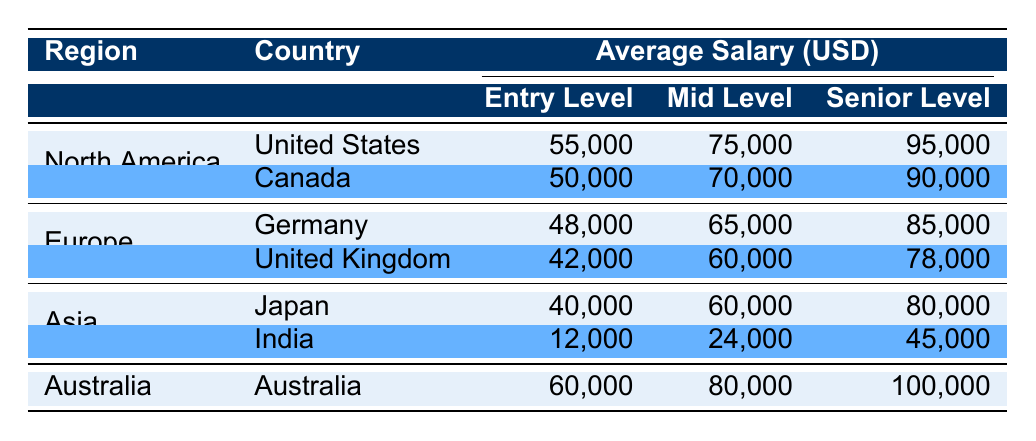What is the average salary for entry-level machinists in Canada? The table shows that the average salary for entry-level machinists in Canada is 50,000 USD.
Answer: 50,000 Which region has the highest average salary for senior-level machinists? By comparing the average salaries for senior-level machinists from all regions, North America (United States: 95,000 USD, Canada: 90,000 USD) has the highest average salary (95,000 USD).
Answer: North America Is the average salary for mid-level machinists in Germany higher than in Japan? The table shows mid-level salaries: Germany: 65,000 USD and Japan: 60,000 USD. Since 65,000 is greater than 60,000, the statement is true.
Answer: Yes What is the combined average salary for all entry-level machinists across the table? The entry-level salaries are: United States (55,000), Canada (50,000), Germany (48,000), United Kingdom (42,000), Japan (40,000), India (12,000), and Australia (60,000). Adding these gives 55,000 + 50,000 + 48,000 + 42,000 + 40,000 + 12,000 + 60,000 = 307,000. There are 7 countries, so the average is 307,000 / 7 = 43,857.14.
Answer: 43,857.14 Is the mid-level salary for machinists in India more than that in Canada? The table shows India's mid-level salary is 24,000 USD and Canada's is 70,000 USD. Since 24,000 is less than 70,000, the answer is false.
Answer: No 